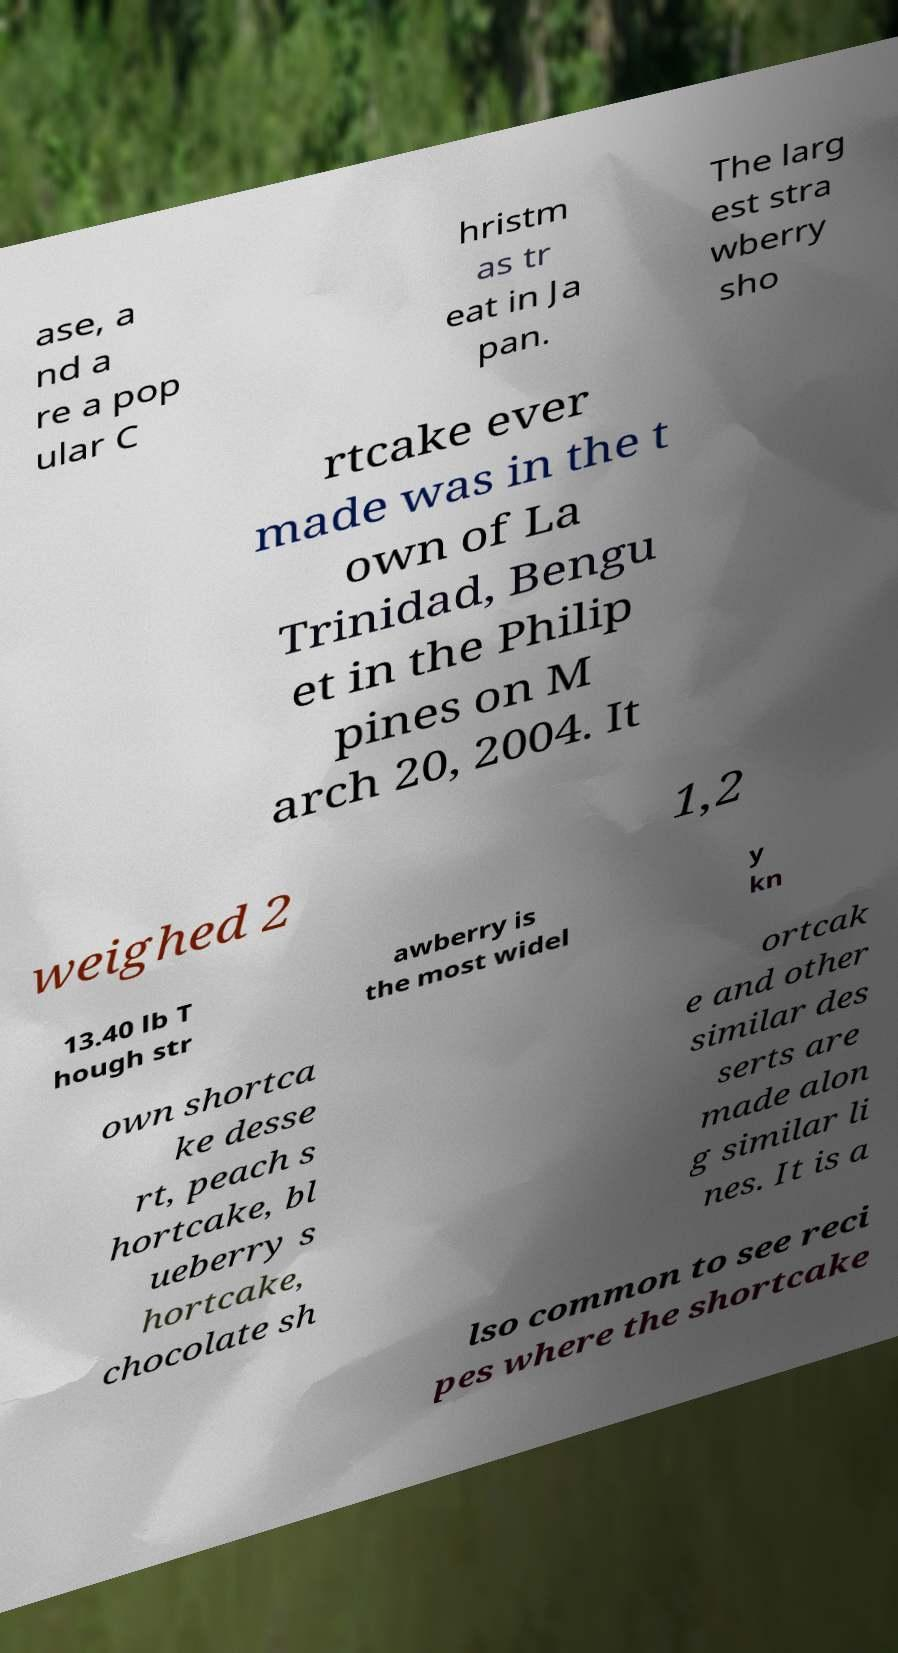For documentation purposes, I need the text within this image transcribed. Could you provide that? ase, a nd a re a pop ular C hristm as tr eat in Ja pan. The larg est stra wberry sho rtcake ever made was in the t own of La Trinidad, Bengu et in the Philip pines on M arch 20, 2004. It weighed 2 1,2 13.40 lb T hough str awberry is the most widel y kn own shortca ke desse rt, peach s hortcake, bl ueberry s hortcake, chocolate sh ortcak e and other similar des serts are made alon g similar li nes. It is a lso common to see reci pes where the shortcake 